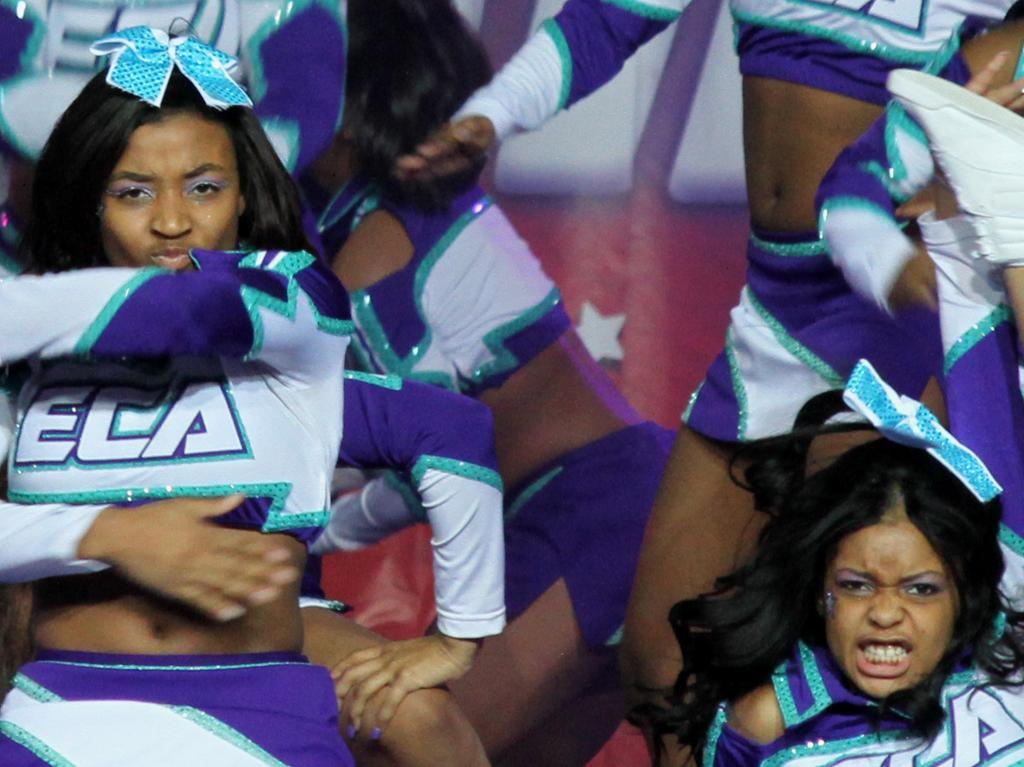What is the common feature among the women in the image? The women are wearing the same dresses. What are the women doing in the image? The women are dancing. Can you describe the attire of the women in the image? The women are wearing dresses. What type of hat is the woman wearing in the image? There is no hat visible in the image; the women are wearing dresses. Can you describe the reaction of the women to the bubble in the image? There is no bubble present in the image, so it is not possible to describe a reaction to it. 